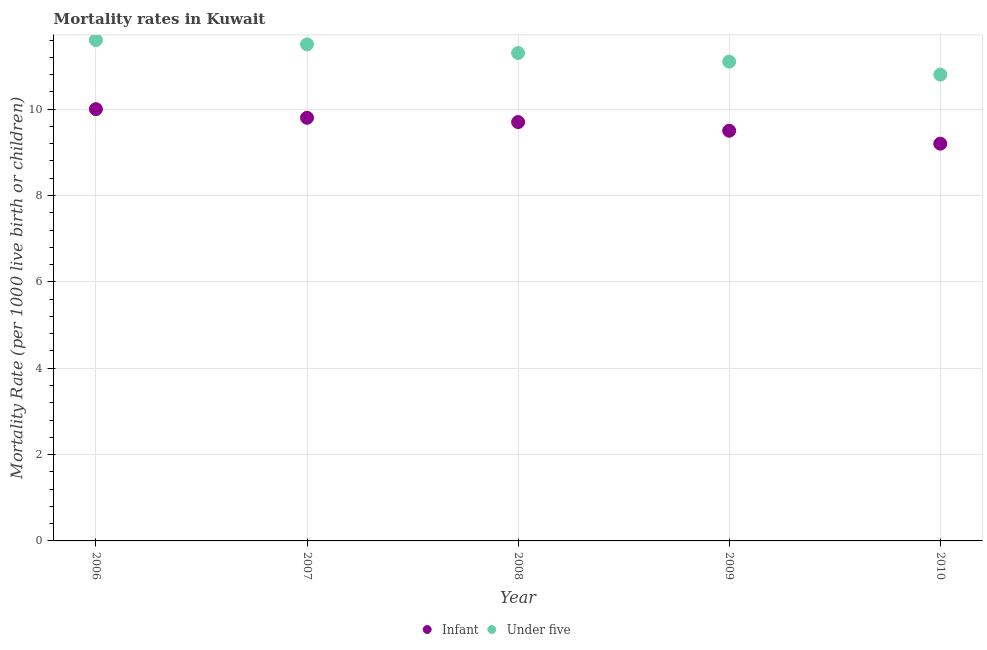In which year was the infant mortality rate maximum?
Offer a terse response. 2006. In which year was the infant mortality rate minimum?
Offer a terse response. 2010. What is the total infant mortality rate in the graph?
Your answer should be very brief. 48.2. What is the difference between the infant mortality rate in 2007 and that in 2009?
Your answer should be compact. 0.3. What is the difference between the infant mortality rate in 2010 and the under-5 mortality rate in 2009?
Your response must be concise. -1.9. What is the average under-5 mortality rate per year?
Offer a terse response. 11.26. In the year 2009, what is the difference between the infant mortality rate and under-5 mortality rate?
Make the answer very short. -1.6. What is the ratio of the under-5 mortality rate in 2007 to that in 2008?
Your answer should be very brief. 1.02. What is the difference between the highest and the second highest infant mortality rate?
Offer a very short reply. 0.2. What is the difference between the highest and the lowest under-5 mortality rate?
Ensure brevity in your answer.  0.8. In how many years, is the under-5 mortality rate greater than the average under-5 mortality rate taken over all years?
Your answer should be very brief. 3. Is the sum of the infant mortality rate in 2006 and 2010 greater than the maximum under-5 mortality rate across all years?
Your answer should be compact. Yes. Is the infant mortality rate strictly less than the under-5 mortality rate over the years?
Offer a terse response. Yes. Are the values on the major ticks of Y-axis written in scientific E-notation?
Your response must be concise. No. Does the graph contain grids?
Give a very brief answer. Yes. Where does the legend appear in the graph?
Your answer should be compact. Bottom center. How many legend labels are there?
Your answer should be compact. 2. How are the legend labels stacked?
Provide a succinct answer. Horizontal. What is the title of the graph?
Offer a very short reply. Mortality rates in Kuwait. Does "Commercial bank branches" appear as one of the legend labels in the graph?
Offer a very short reply. No. What is the label or title of the X-axis?
Your response must be concise. Year. What is the label or title of the Y-axis?
Your answer should be compact. Mortality Rate (per 1000 live birth or children). What is the Mortality Rate (per 1000 live birth or children) in Infant in 2008?
Make the answer very short. 9.7. What is the Mortality Rate (per 1000 live birth or children) in Infant in 2009?
Your answer should be very brief. 9.5. What is the Mortality Rate (per 1000 live birth or children) in Under five in 2010?
Provide a succinct answer. 10.8. Across all years, what is the maximum Mortality Rate (per 1000 live birth or children) in Infant?
Offer a very short reply. 10. Across all years, what is the maximum Mortality Rate (per 1000 live birth or children) in Under five?
Give a very brief answer. 11.6. Across all years, what is the minimum Mortality Rate (per 1000 live birth or children) in Infant?
Provide a short and direct response. 9.2. Across all years, what is the minimum Mortality Rate (per 1000 live birth or children) of Under five?
Ensure brevity in your answer.  10.8. What is the total Mortality Rate (per 1000 live birth or children) in Infant in the graph?
Your answer should be compact. 48.2. What is the total Mortality Rate (per 1000 live birth or children) of Under five in the graph?
Provide a succinct answer. 56.3. What is the difference between the Mortality Rate (per 1000 live birth or children) of Under five in 2006 and that in 2009?
Ensure brevity in your answer.  0.5. What is the difference between the Mortality Rate (per 1000 live birth or children) in Under five in 2006 and that in 2010?
Offer a very short reply. 0.8. What is the difference between the Mortality Rate (per 1000 live birth or children) of Infant in 2007 and that in 2008?
Your answer should be very brief. 0.1. What is the difference between the Mortality Rate (per 1000 live birth or children) in Under five in 2007 and that in 2008?
Offer a very short reply. 0.2. What is the difference between the Mortality Rate (per 1000 live birth or children) in Under five in 2007 and that in 2009?
Your answer should be compact. 0.4. What is the difference between the Mortality Rate (per 1000 live birth or children) of Under five in 2008 and that in 2009?
Ensure brevity in your answer.  0.2. What is the difference between the Mortality Rate (per 1000 live birth or children) of Under five in 2008 and that in 2010?
Provide a succinct answer. 0.5. What is the difference between the Mortality Rate (per 1000 live birth or children) of Infant in 2009 and that in 2010?
Make the answer very short. 0.3. What is the difference between the Mortality Rate (per 1000 live birth or children) of Under five in 2009 and that in 2010?
Offer a terse response. 0.3. What is the difference between the Mortality Rate (per 1000 live birth or children) in Infant in 2006 and the Mortality Rate (per 1000 live birth or children) in Under five in 2010?
Offer a terse response. -0.8. What is the difference between the Mortality Rate (per 1000 live birth or children) of Infant in 2007 and the Mortality Rate (per 1000 live birth or children) of Under five in 2008?
Make the answer very short. -1.5. What is the difference between the Mortality Rate (per 1000 live birth or children) in Infant in 2007 and the Mortality Rate (per 1000 live birth or children) in Under five in 2009?
Your answer should be very brief. -1.3. What is the difference between the Mortality Rate (per 1000 live birth or children) of Infant in 2008 and the Mortality Rate (per 1000 live birth or children) of Under five in 2009?
Your response must be concise. -1.4. What is the difference between the Mortality Rate (per 1000 live birth or children) of Infant in 2008 and the Mortality Rate (per 1000 live birth or children) of Under five in 2010?
Keep it short and to the point. -1.1. What is the difference between the Mortality Rate (per 1000 live birth or children) in Infant in 2009 and the Mortality Rate (per 1000 live birth or children) in Under five in 2010?
Ensure brevity in your answer.  -1.3. What is the average Mortality Rate (per 1000 live birth or children) in Infant per year?
Your answer should be compact. 9.64. What is the average Mortality Rate (per 1000 live birth or children) in Under five per year?
Your answer should be compact. 11.26. In the year 2007, what is the difference between the Mortality Rate (per 1000 live birth or children) in Infant and Mortality Rate (per 1000 live birth or children) in Under five?
Make the answer very short. -1.7. In the year 2008, what is the difference between the Mortality Rate (per 1000 live birth or children) in Infant and Mortality Rate (per 1000 live birth or children) in Under five?
Provide a succinct answer. -1.6. In the year 2009, what is the difference between the Mortality Rate (per 1000 live birth or children) in Infant and Mortality Rate (per 1000 live birth or children) in Under five?
Offer a terse response. -1.6. In the year 2010, what is the difference between the Mortality Rate (per 1000 live birth or children) of Infant and Mortality Rate (per 1000 live birth or children) of Under five?
Provide a short and direct response. -1.6. What is the ratio of the Mortality Rate (per 1000 live birth or children) in Infant in 2006 to that in 2007?
Make the answer very short. 1.02. What is the ratio of the Mortality Rate (per 1000 live birth or children) in Under five in 2006 to that in 2007?
Your answer should be compact. 1.01. What is the ratio of the Mortality Rate (per 1000 live birth or children) of Infant in 2006 to that in 2008?
Your answer should be compact. 1.03. What is the ratio of the Mortality Rate (per 1000 live birth or children) of Under five in 2006 to that in 2008?
Your answer should be compact. 1.03. What is the ratio of the Mortality Rate (per 1000 live birth or children) in Infant in 2006 to that in 2009?
Provide a succinct answer. 1.05. What is the ratio of the Mortality Rate (per 1000 live birth or children) of Under five in 2006 to that in 2009?
Provide a succinct answer. 1.04. What is the ratio of the Mortality Rate (per 1000 live birth or children) of Infant in 2006 to that in 2010?
Provide a succinct answer. 1.09. What is the ratio of the Mortality Rate (per 1000 live birth or children) in Under five in 2006 to that in 2010?
Give a very brief answer. 1.07. What is the ratio of the Mortality Rate (per 1000 live birth or children) of Infant in 2007 to that in 2008?
Your response must be concise. 1.01. What is the ratio of the Mortality Rate (per 1000 live birth or children) of Under five in 2007 to that in 2008?
Your answer should be very brief. 1.02. What is the ratio of the Mortality Rate (per 1000 live birth or children) in Infant in 2007 to that in 2009?
Your answer should be very brief. 1.03. What is the ratio of the Mortality Rate (per 1000 live birth or children) of Under five in 2007 to that in 2009?
Your response must be concise. 1.04. What is the ratio of the Mortality Rate (per 1000 live birth or children) of Infant in 2007 to that in 2010?
Keep it short and to the point. 1.07. What is the ratio of the Mortality Rate (per 1000 live birth or children) of Under five in 2007 to that in 2010?
Your response must be concise. 1.06. What is the ratio of the Mortality Rate (per 1000 live birth or children) of Infant in 2008 to that in 2009?
Give a very brief answer. 1.02. What is the ratio of the Mortality Rate (per 1000 live birth or children) in Under five in 2008 to that in 2009?
Provide a short and direct response. 1.02. What is the ratio of the Mortality Rate (per 1000 live birth or children) of Infant in 2008 to that in 2010?
Your answer should be compact. 1.05. What is the ratio of the Mortality Rate (per 1000 live birth or children) of Under five in 2008 to that in 2010?
Your answer should be compact. 1.05. What is the ratio of the Mortality Rate (per 1000 live birth or children) of Infant in 2009 to that in 2010?
Make the answer very short. 1.03. What is the ratio of the Mortality Rate (per 1000 live birth or children) in Under five in 2009 to that in 2010?
Keep it short and to the point. 1.03. What is the difference between the highest and the second highest Mortality Rate (per 1000 live birth or children) of Infant?
Keep it short and to the point. 0.2. 